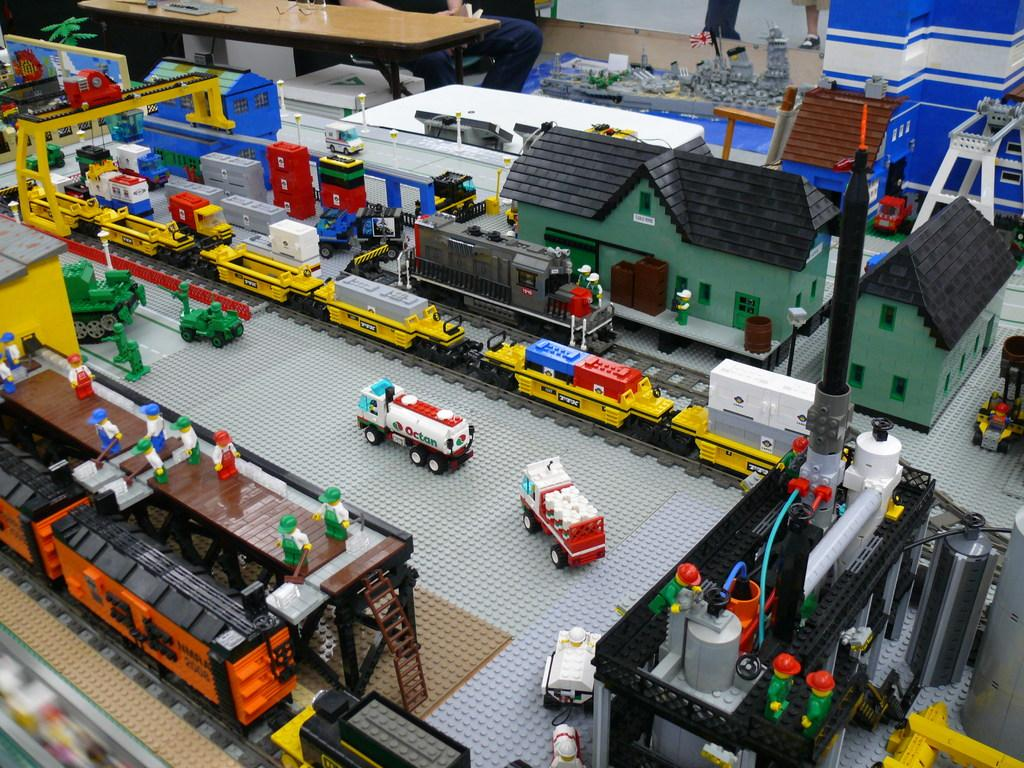What type of vehicles can be seen in the image? There are toy cars in the image. What type of structures are present in the image? There are houses in the image. What mode of transportation is also visible in the image? There is a train in the image. What is the train traveling on in the image? There is a railway track in the image. Who or what else is present in the image? There are people in the image. What additional item can be seen in the image? There is a cloth in the image. What list of suggestions can be seen in the image? There is no list or suggestions present in the image. What cast of characters is featured in the image? The image does not depict a cast of characters; it features toy cars, houses, a train, railway track, people, and a cloth. 